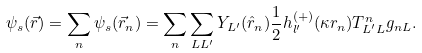<formula> <loc_0><loc_0><loc_500><loc_500>\psi _ { s } ( \vec { r } ) = \sum _ { n } \psi _ { s } ( \vec { r } _ { n } ) = \sum _ { n } \sum _ { L L ^ { \prime } } Y _ { L ^ { \prime } } ( \hat { r } _ { n } ) \frac { 1 } { 2 } h _ { l ^ { \prime } } ^ { ( + ) } ( \kappa r _ { n } ) T _ { L ^ { \prime } L } ^ { n } g _ { n L } .</formula> 